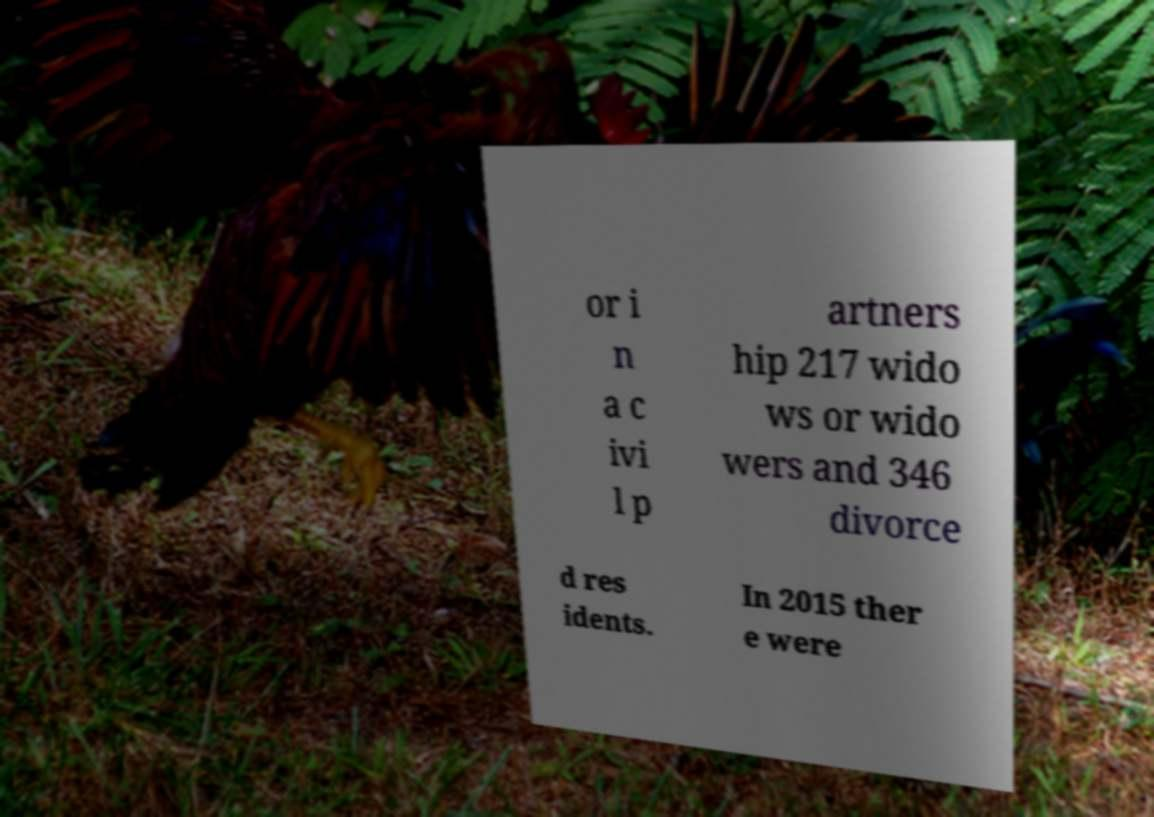Could you extract and type out the text from this image? or i n a c ivi l p artners hip 217 wido ws or wido wers and 346 divorce d res idents. In 2015 ther e were 